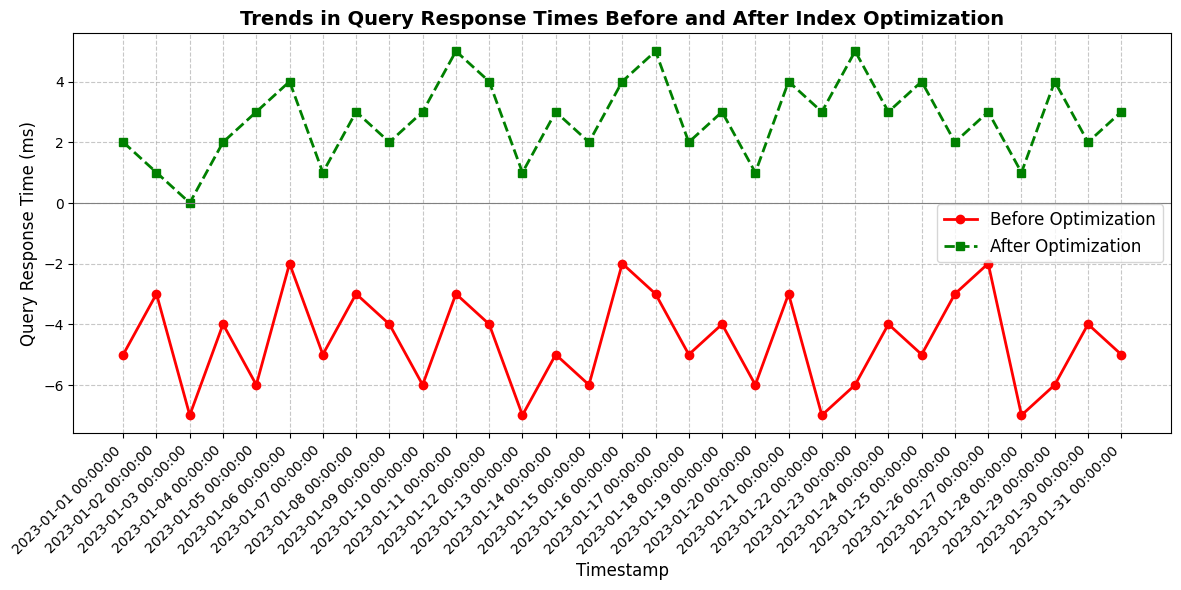What's the general trend observed for query response times before and after optimization? The figure shows two distinct lines, one for before optimization (red) and one for after optimization (green). The red line (before optimization) generally stays in the negative range, indicating negative response times, while the green line (after optimization) primarily remains in the positive range, indicating improved response times. Overall, there's a noticeable improvement in response times after optimization.
Answer: Response times improved after optimization What is the maximum query response time before optimization? By examining the highest point of the red line (Before Optimization), the maximum value observed is -2 milliseconds on 2023-01-06 and 2023-01-27.
Answer: -2 milliseconds What is the minimum query response time after optimization? By examining the lowest point of the green line (After Optimization), the minimum value observed is 0 milliseconds on 2023-01-03.
Answer: 0 milliseconds On which date did the query response time before optimization record its lowest value, and what was that value? By examining the lowest point of the red line (Before Optimization), the minimum value observed is -7 milliseconds. This occurred on 2023-01-03, 2023-01-13, 2023-01-22, and 2023-01-28.
Answer: -7 milliseconds on 2023-01-03, 2023-01-13, 2023-01-22, and 2023-01-28 How did query response times change on 2023-01-03 after optimization compared to before optimization? On 2023-01-03, the query response time before optimization was -7 milliseconds and after optimization was 0 milliseconds. The change is 0 - (-7) = 7 milliseconds improvement.
Answer: 7 milliseconds improvement What is the average query response time after optimization? Sum the query response times after optimization and divide by the number of data points. The total sum is (2+1+0+2+3+4+1+3+2+3+5+4+1+3+2+4+5+2+3+1+4+3+5+3+4+2+3+1+4+2+3) = 92. There are 31 data points. The average is 92/31 ≈ 2.97 milliseconds.
Answer: 2.97 milliseconds How many days did the query response time after optimization exceed the value of 3 milliseconds? Count the days where the green line (After Optimization) is above the value of 3 milliseconds: 2023-01-06, 2023-01-11, 2023-01-16, 2023-01-17, 2023-01-21, 2023-01-23, 2023-01-25, 2023-01-27, 2023-01-29 (9 days in total).
Answer: 9 days What color represents the query response time before optimization, and what color represents the response time after optimization in the figure? The figure uses red to represent query response times before optimization and green to represent query response times after optimization.
Answer: Red for before optimization, green for after optimization Is there any day where the query response times before and after optimization are the same? By checking both lines (Before Optimization and After Optimization), there is no day where the two lines intersect or have the same value.
Answer: No, there is no such day 